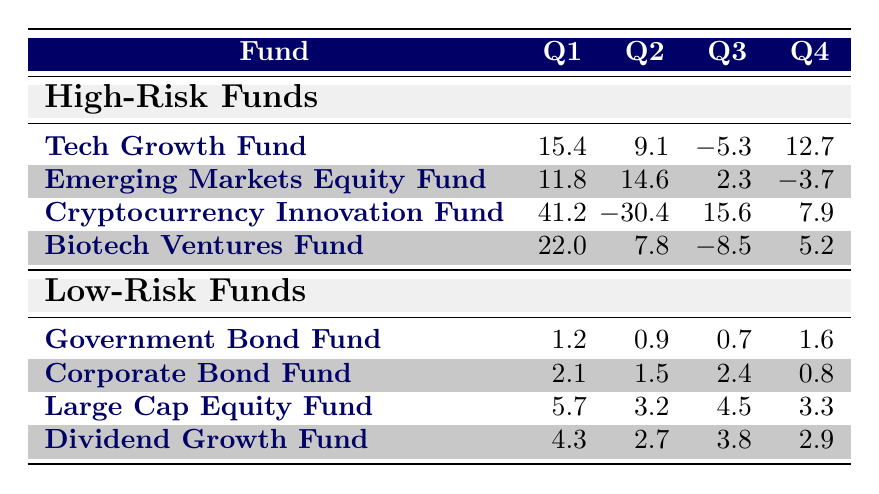What was the highest quarterly return for the Tech Growth Fund? The Tech Growth Fund had returns of 15.4%, 9.1%, -5.3%, and 12.7% over the four quarters. The highest return is 15.4% in Q1.
Answer: 15.4% Which low-risk fund had the highest return in Q2? Among the low-risk funds, the returns in Q2 were 0.9% for the Government Bond Fund, 1.5% for the Corporate Bond Fund, 3.2% for the Large Cap Equity Fund, and 2.7% for the Dividend Growth Fund. Therefore, the Large Cap Equity Fund had the highest return in Q2 at 3.2%.
Answer: 3.2% What is the average quarterly return for all high-risk funds combined in Q3? The returns for Q3 were -5.3% for the Tech Growth Fund, 2.3% for the Emerging Markets Equity Fund, 15.6% for the Cryptocurrency Innovation Fund, and -8.5% for the Biotech Ventures Fund. Summing these gives (-5.3 + 2.3 + 15.6 - 8.5) = 4.1%. Dividing by 4 (the number of funds) gives an average of 4.1% / 4 = 1.025%.
Answer: 1.025% Did all low-risk funds have positive returns in Q4? The returns for Q4 were 1.6% for the Government Bond Fund, 0.8% for the Corporate Bond Fund, 3.3% for the Large Cap Equity Fund, and 2.9% for the Dividend Growth Fund. Since the Corporate Bond Fund had a positive return (0.8%), we conclude that yes, all low-risk funds had positive returns in Q4.
Answer: Yes Which fund had the largest return in Q1, high-risk or low-risk? In Q1, the highest returns were 15.4% for the Tech Growth Fund and 5.7% for the Large Cap Equity Fund. The Tech Growth Fund had a larger return.
Answer: Tech Growth Fund 